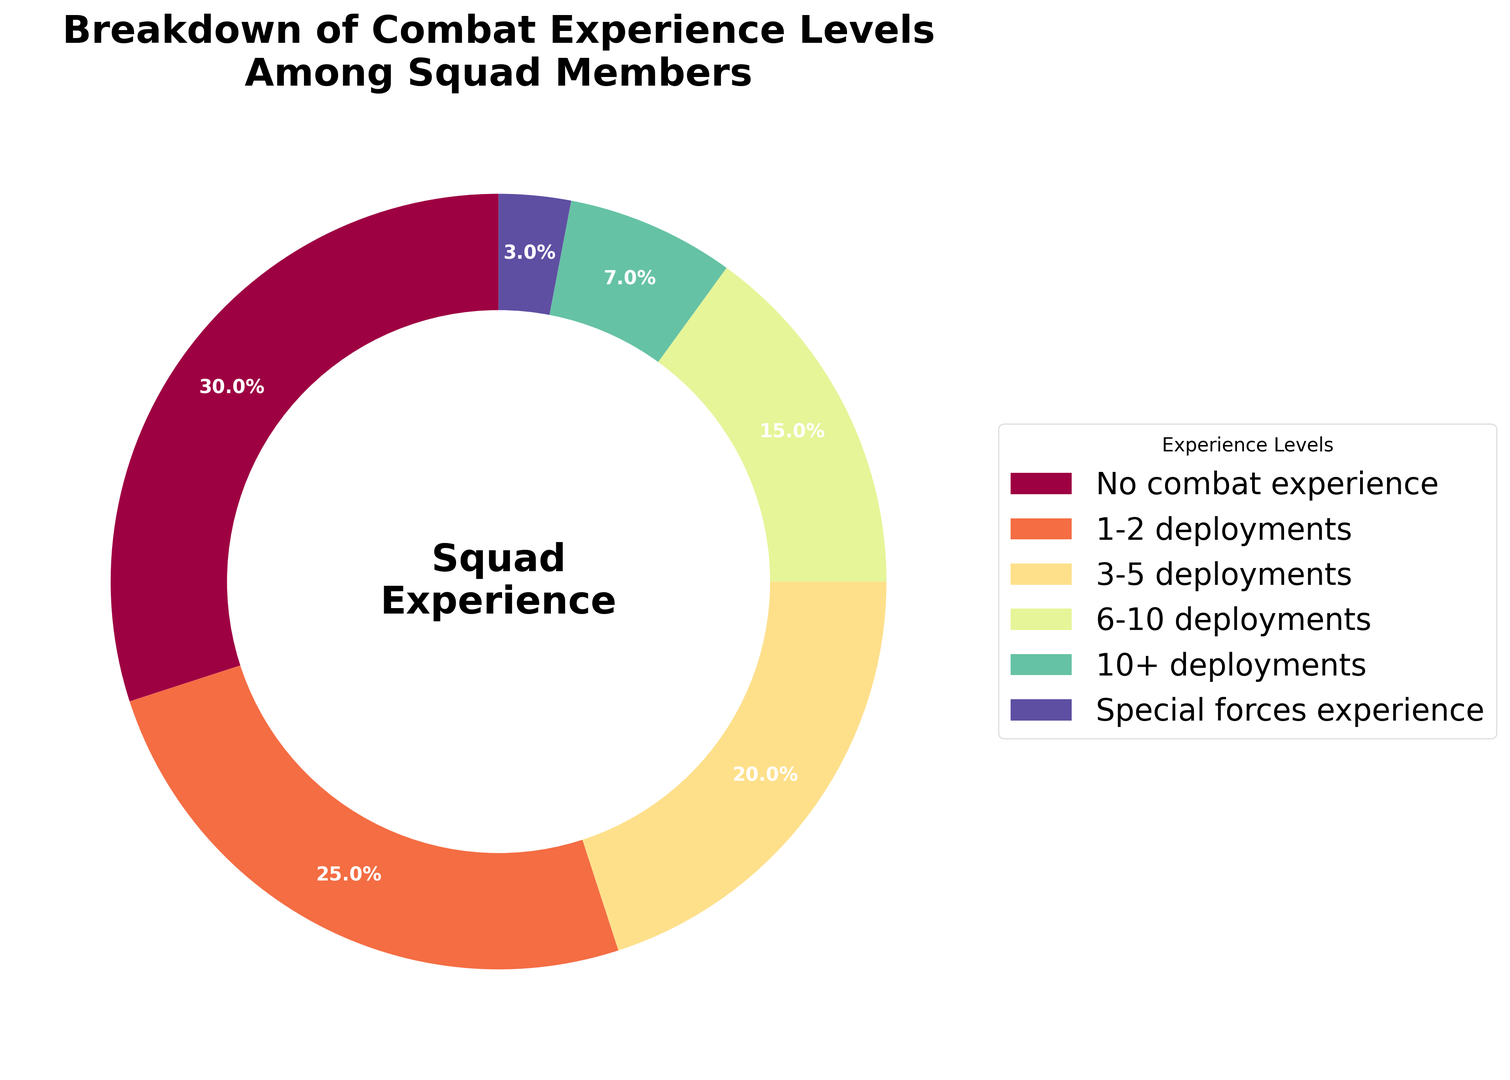What percentage of squad members have either no combat experience or 1-2 deployments? We need to sum the percentages of the 'No combat experience' and '1-2 deployments' categories. That is, 30% + 25% = 55%.
Answer: 55% Which experience level has the smallest representation in the squad? By looking at the different segments of the ring chart and their corresponding percentages, the 'Special forces experience' category has the smallest percentage at 3%.
Answer: Special forces experience How much larger is the percentage of members with no combat experience compared to those with 10+ deployments? The percentage of 'No combat experience' is 30%, while the '10+ deployments' is 7%. The difference is 30% - 7% = 23%.
Answer: 23% What is the combined percentage of squad members with at least 6 deployments? We sum the percentages of the '6-10 deployments' and '10+ deployments' categories. That is, 15% + 7% = 22%.
Answer: 22% Which color represents members with 1-2 deployments? Based on the figure, the segment displaying '1-2 deployments' is most likely positioned after 'No combat experience' and uses the color next in the sequence. It varies depending on the exact pie visuals but typically could be a noticeable bright color like yellow or orange.
Answer: (a specific color visible from the chart) Is the percentage of members with no combat experience greater than the total percentage of members with three or more deployments? Members with three or more deployments include '3-5 deployments', '6-10 deployments', and '10+ deployments', summing to 20% + 15% + 7% which equals 42%. 'No combat experience' is 30%, so 42% > 30%.
Answer: No What is the difference in the percentage of members with 3-5 deployments compared to those with 6-10 deployments? The percentage for '3-5 deployments' is 20% while for '6-10 deployments' it is 15%. The difference is 20% - 15% = 5%.
Answer: 5% How many categories of experience levels are shown in the ring chart? Counting the different sections labeled around the ring chart we observe a total of six categories.
Answer: 6 